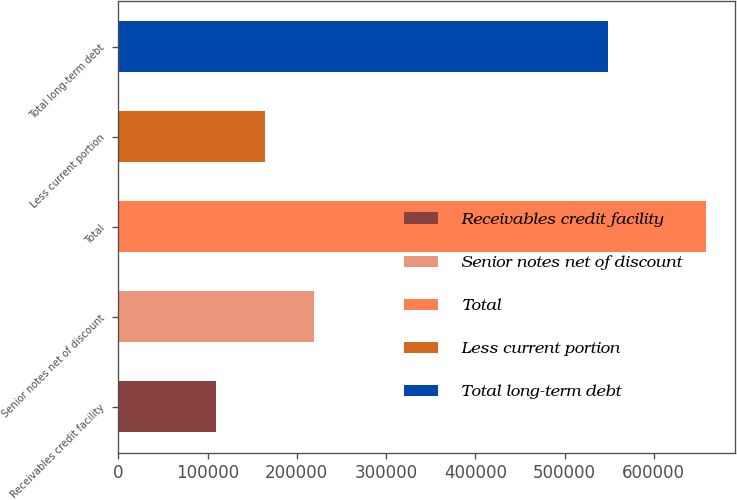<chart> <loc_0><loc_0><loc_500><loc_500><bar_chart><fcel>Receivables credit facility<fcel>Senior notes net of discount<fcel>Total<fcel>Less current portion<fcel>Total long-term debt<nl><fcel>109000<fcel>218820<fcel>658099<fcel>163910<fcel>549099<nl></chart> 